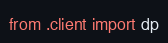Convert code to text. <code><loc_0><loc_0><loc_500><loc_500><_Python_>from .client import dp</code> 